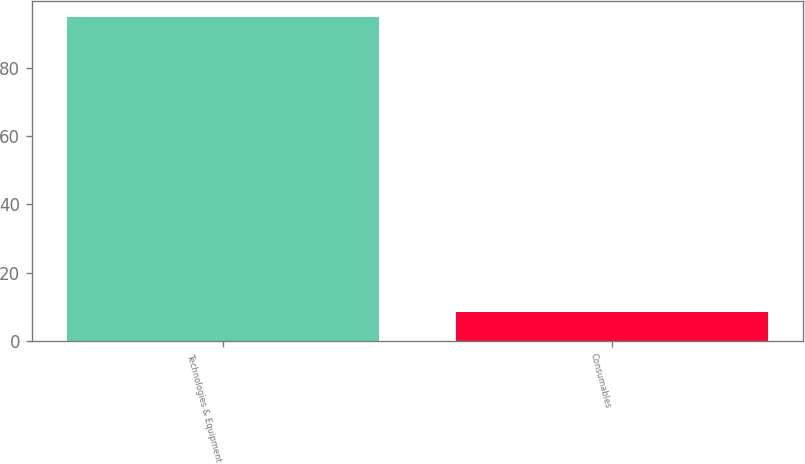<chart> <loc_0><loc_0><loc_500><loc_500><bar_chart><fcel>Technologies & Equipment<fcel>Consumables<nl><fcel>94.8<fcel>8.5<nl></chart> 